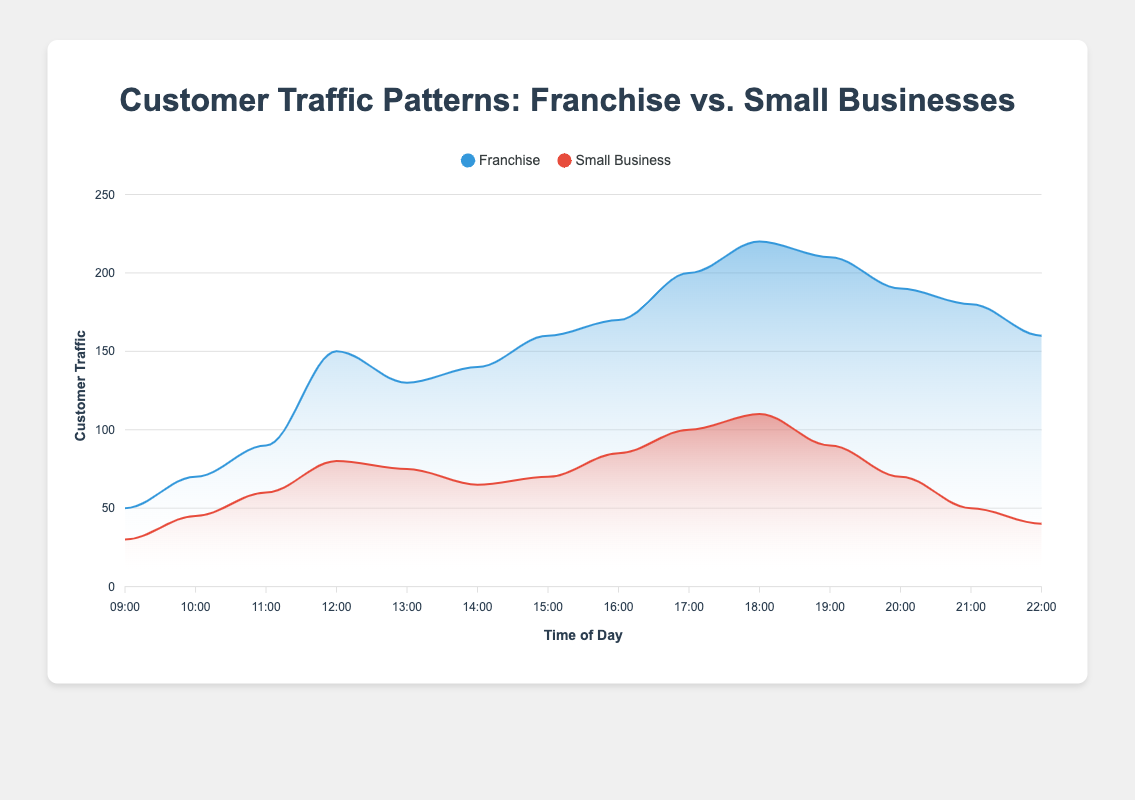What is the title of the chart? The title of the chart is displayed at the top and reads "Customer Traffic Patterns: Franchise vs. Small Businesses"
Answer: Customer Traffic Patterns: Franchise vs. Small Businesses What time of day has the highest customer traffic for the franchise? Observing the peaks in the franchise area chart, the highest value occurs at "18:00" with 220 customers
Answer: 18:00 How many time points are presented in the chart? The x-axis displays the times from "09:00" to "22:00". Counting each hourly point results in 14 time points.
Answer: 14 Around what time does the customer traffic for small businesses peak? The highest point in the area chart for small businesses is seen at "18:00" with 110 customers
Answer: 18:00 Compare the customer traffic at 12:00 between franchises and small businesses. At 12:00, franchises have 150 customers, and small businesses have 80 customers. This can be read directly from the respective peaks in the chart at that time.
Answer: Franchises: 150, Small Businesses: 80 What is the range of customer traffic for franchises throughout the day? The minimum value in the franchise area is at "09:00" with 50 customers, and the maximum is at "18:00" with 220 customers. Hence the range is 220 - 50 = 170
Answer: 170 By how much does the franchise customer traffic surpass small business customer traffic at 10:00? At 10:00, franchise traffic is 70 customers and small business traffic is 45 customers. The difference is calculated as 70 - 45 = 25 customers
Answer: 25 Which has a greater decline in customer traffic between 19:00 and 22:00, franchise or small business? For franchises, the traffic declines from 210 to 160, a difference of 50. For small businesses, the traffic declines from 90 to 40, a difference of 50. Both declines are equal.
Answer: Both: 50 At what times does franchise traffic start consistently exceeding small business traffic by at least double? Franchise traffic is consistently at least double small business traffic from 17:00 onwards. At 17:00: 200 vs. 100, 18:00: 220 vs. 110, 19:00: 210 vs. 90, etc.
Answer: 17:00 onwards How does customer traffic for franchises change from 15:00 to 17:00? Between 15:00 and 17:00, franchise traffic rises from 160 to 200, which is an increase of 200 - 160 = 40 customers over two hours.
Answer: Increases by 40 